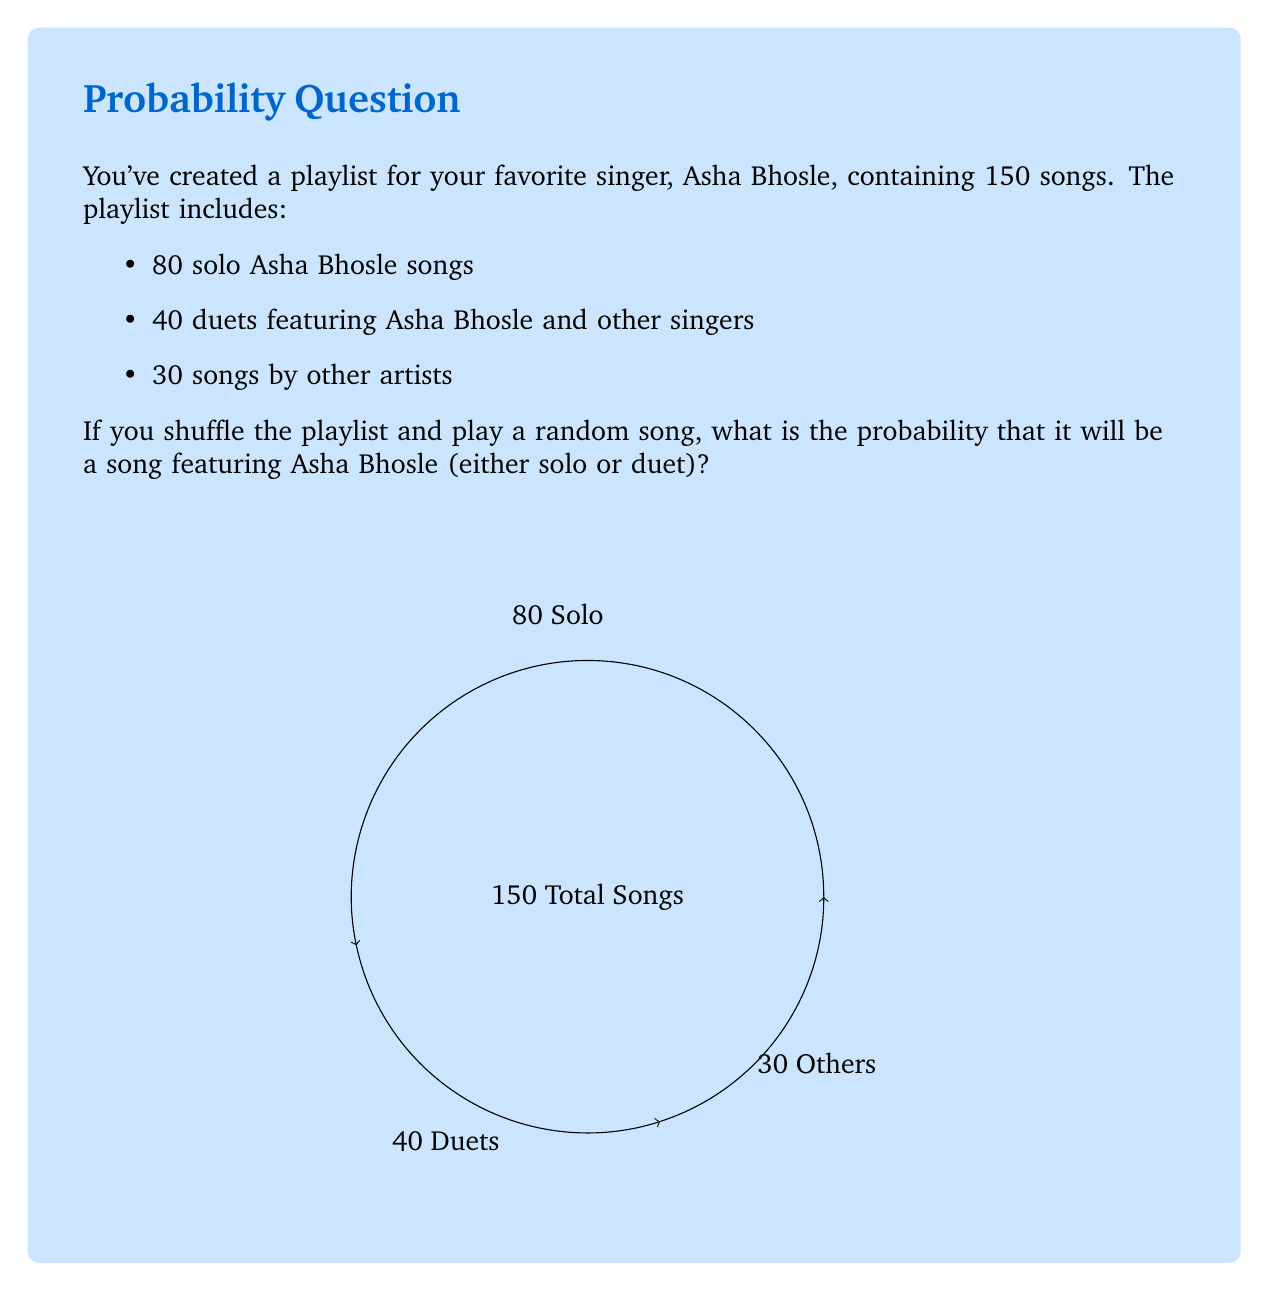Could you help me with this problem? Let's approach this step-by-step:

1) First, we need to identify the total number of songs in the playlist and the number of songs featuring Asha Bhosle.

   Total songs = 150
   Songs featuring Asha Bhosle = Solo songs + Duets = 80 + 40 = 120

2) The probability of an event is calculated by dividing the number of favorable outcomes by the total number of possible outcomes.

3) In this case:
   - Favorable outcomes: Songs featuring Asha Bhosle = 120
   - Total possible outcomes: All songs in the playlist = 150

4) Therefore, the probability is:

   $$P(\text{Asha Bhosle song}) = \frac{\text{Songs featuring Asha Bhosle}}{\text{Total songs}} = \frac{120}{150}$$

5) Simplify the fraction:

   $$\frac{120}{150} = \frac{4}{5} = 0.8$$

Thus, the probability of randomly selecting a song featuring Asha Bhosle from the playlist is $\frac{4}{5}$ or 0.8 or 80%.
Answer: $\frac{4}{5}$ or 0.8 